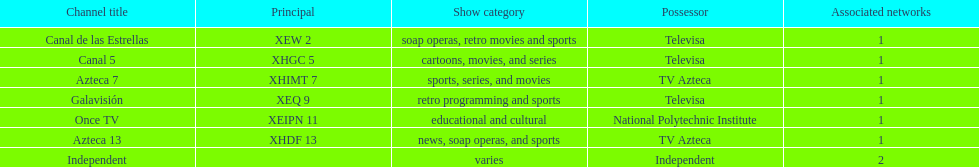Name a station that shows sports but is not televisa. Azteca 7. 